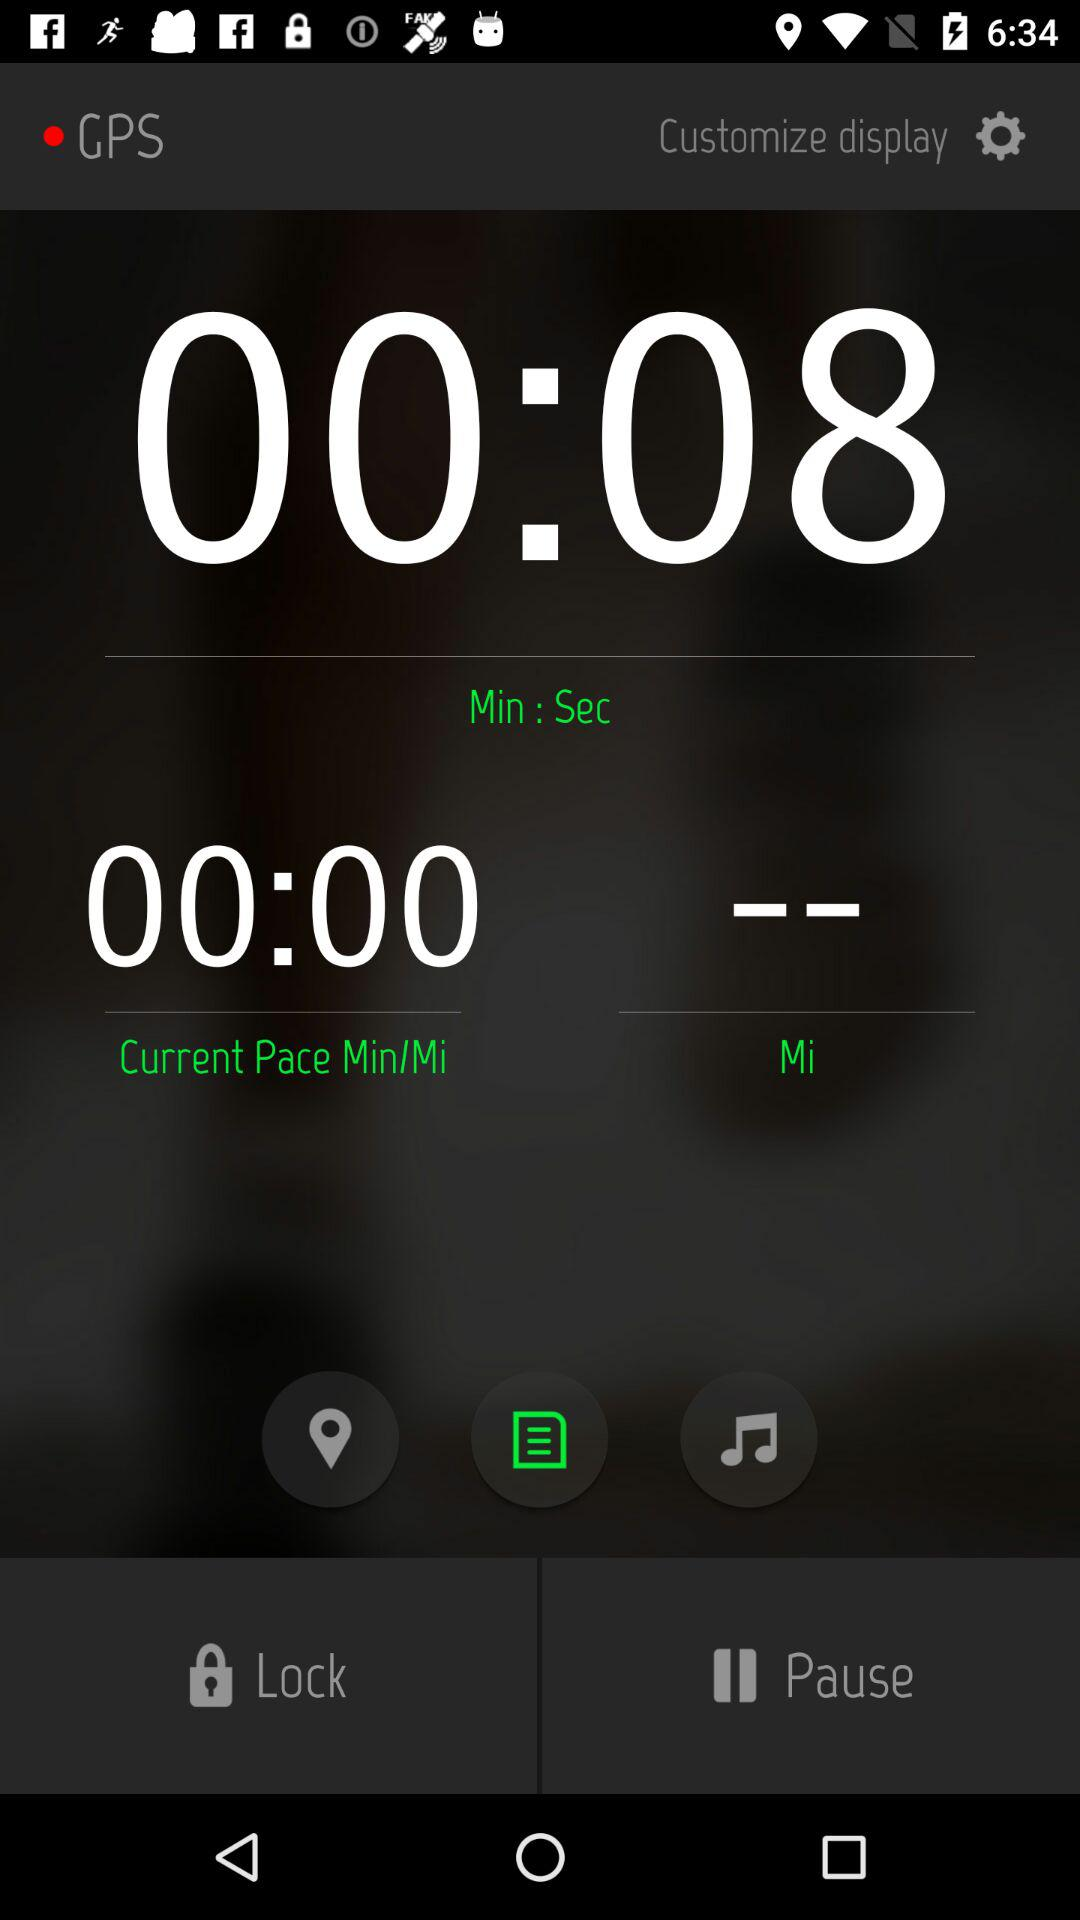What is the nature of this display?
When the provided information is insufficient, respond with <no answer>. <no answer> 